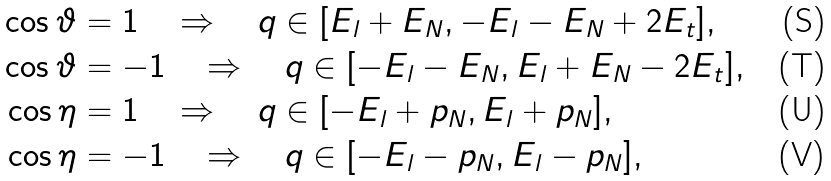<formula> <loc_0><loc_0><loc_500><loc_500>\cos \vartheta & = 1 \quad \Rightarrow \quad q \in [ E _ { l } + E _ { N } , - E _ { l } - E _ { N } + 2 E _ { t } ] , \\ \cos \vartheta & = - 1 \quad \Rightarrow \quad q \in [ - E _ { l } - E _ { N } , E _ { l } + E _ { N } - 2 E _ { t } ] , \\ \cos \eta & = 1 \quad \Rightarrow \quad q \in [ - E _ { l } + p _ { N } , E _ { l } + p _ { N } ] , \\ \cos \eta & = - 1 \quad \Rightarrow \quad q \in [ - E _ { l } - p _ { N } , E _ { l } - p _ { N } ] ,</formula> 